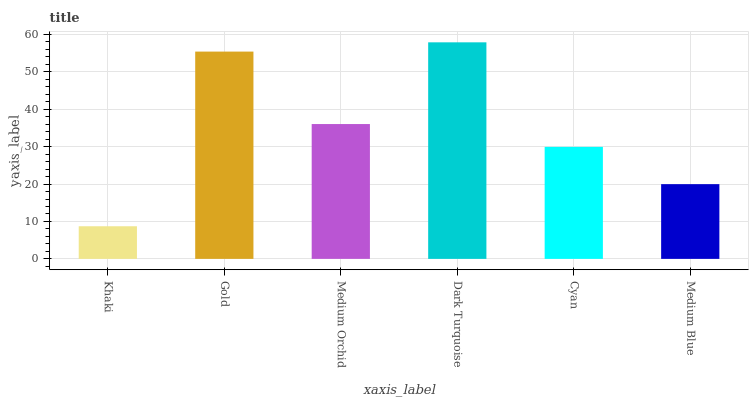Is Khaki the minimum?
Answer yes or no. Yes. Is Dark Turquoise the maximum?
Answer yes or no. Yes. Is Gold the minimum?
Answer yes or no. No. Is Gold the maximum?
Answer yes or no. No. Is Gold greater than Khaki?
Answer yes or no. Yes. Is Khaki less than Gold?
Answer yes or no. Yes. Is Khaki greater than Gold?
Answer yes or no. No. Is Gold less than Khaki?
Answer yes or no. No. Is Medium Orchid the high median?
Answer yes or no. Yes. Is Cyan the low median?
Answer yes or no. Yes. Is Dark Turquoise the high median?
Answer yes or no. No. Is Gold the low median?
Answer yes or no. No. 